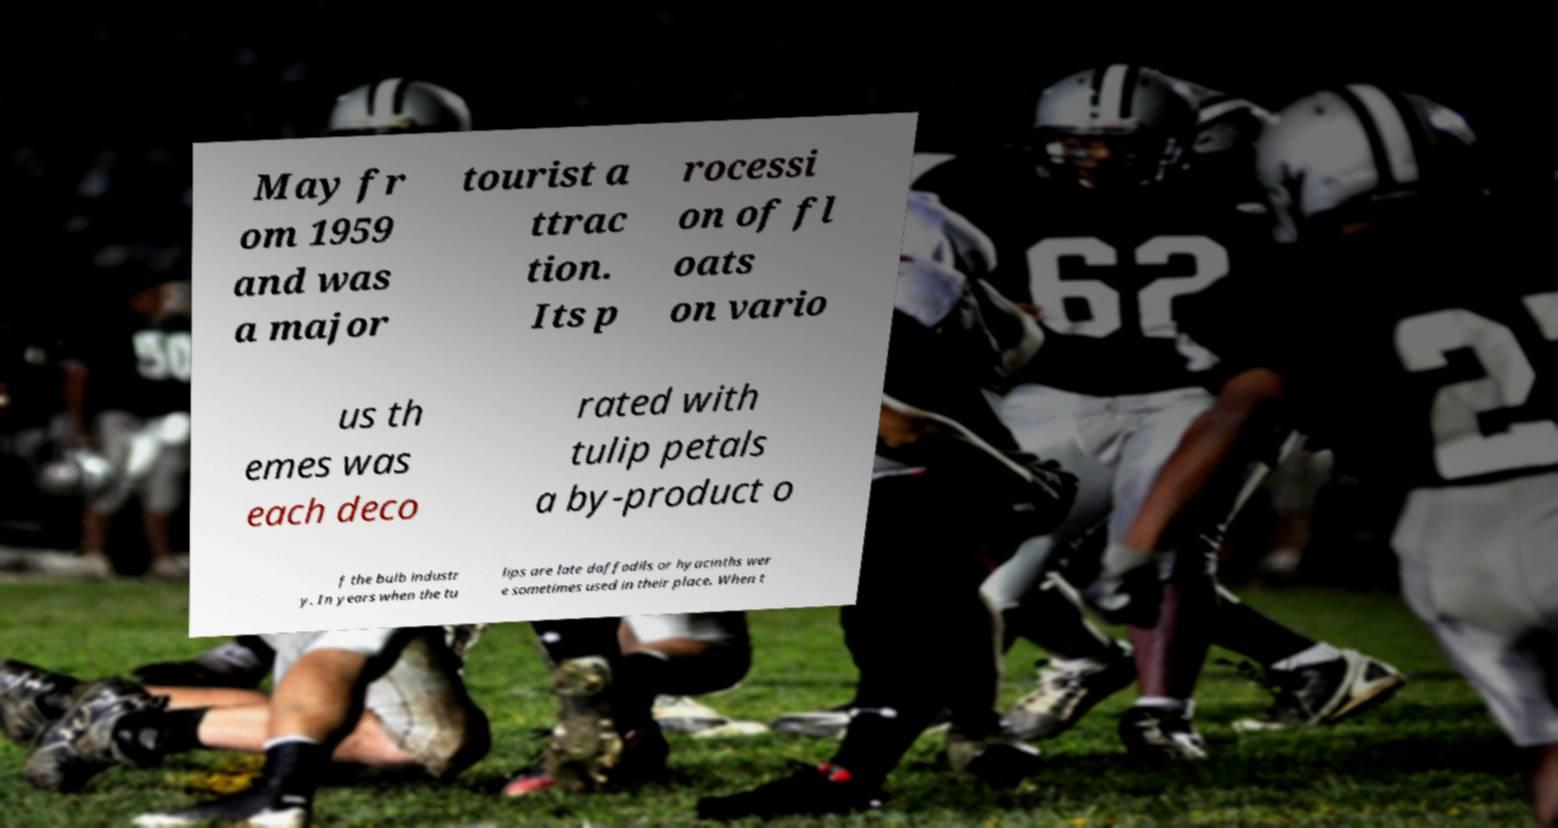For documentation purposes, I need the text within this image transcribed. Could you provide that? May fr om 1959 and was a major tourist a ttrac tion. Its p rocessi on of fl oats on vario us th emes was each deco rated with tulip petals a by-product o f the bulb industr y. In years when the tu lips are late daffodils or hyacinths wer e sometimes used in their place. When t 